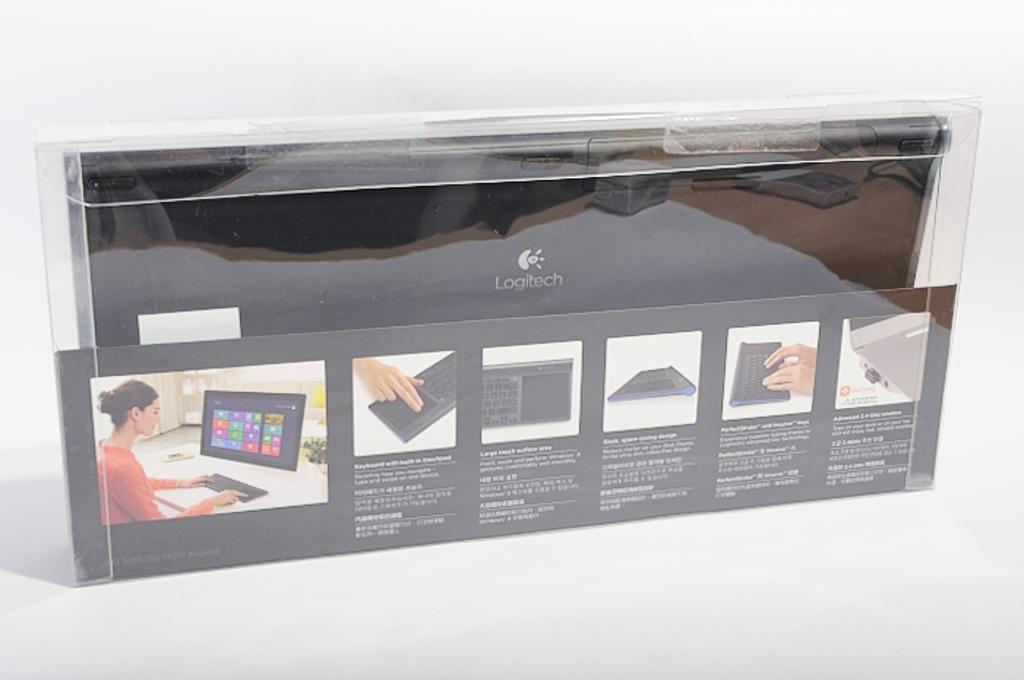Provide a one-sentence caption for the provided image. Computer Monitor and Keyboard from Logitech that comes in a case. 